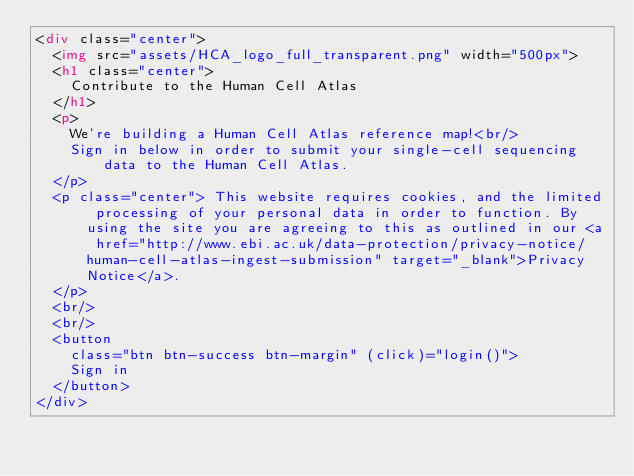Convert code to text. <code><loc_0><loc_0><loc_500><loc_500><_HTML_><div class="center">
  <img src="assets/HCA_logo_full_transparent.png" width="500px">
  <h1 class="center">
    Contribute to the Human Cell Atlas
  </h1>
  <p>
    We're building a Human Cell Atlas reference map!<br/>
    Sign in below in order to submit your single-cell sequencing data to the Human Cell Atlas.
  </p>
  <p class="center"> This website requires cookies, and the limited processing of your personal data in order to function. By using the site you are agreeing to this as outlined in our <a href="http://www.ebi.ac.uk/data-protection/privacy-notice/human-cell-atlas-ingest-submission" target="_blank">Privacy Notice</a>.
  </p>
  <br/>
  <br/>
  <button
    class="btn btn-success btn-margin" (click)="login()">
    Sign in
  </button>
</div>

</code> 